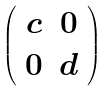<formula> <loc_0><loc_0><loc_500><loc_500>\left ( \begin{array} { c c } c & 0 \\ 0 & d \end{array} \right )</formula> 